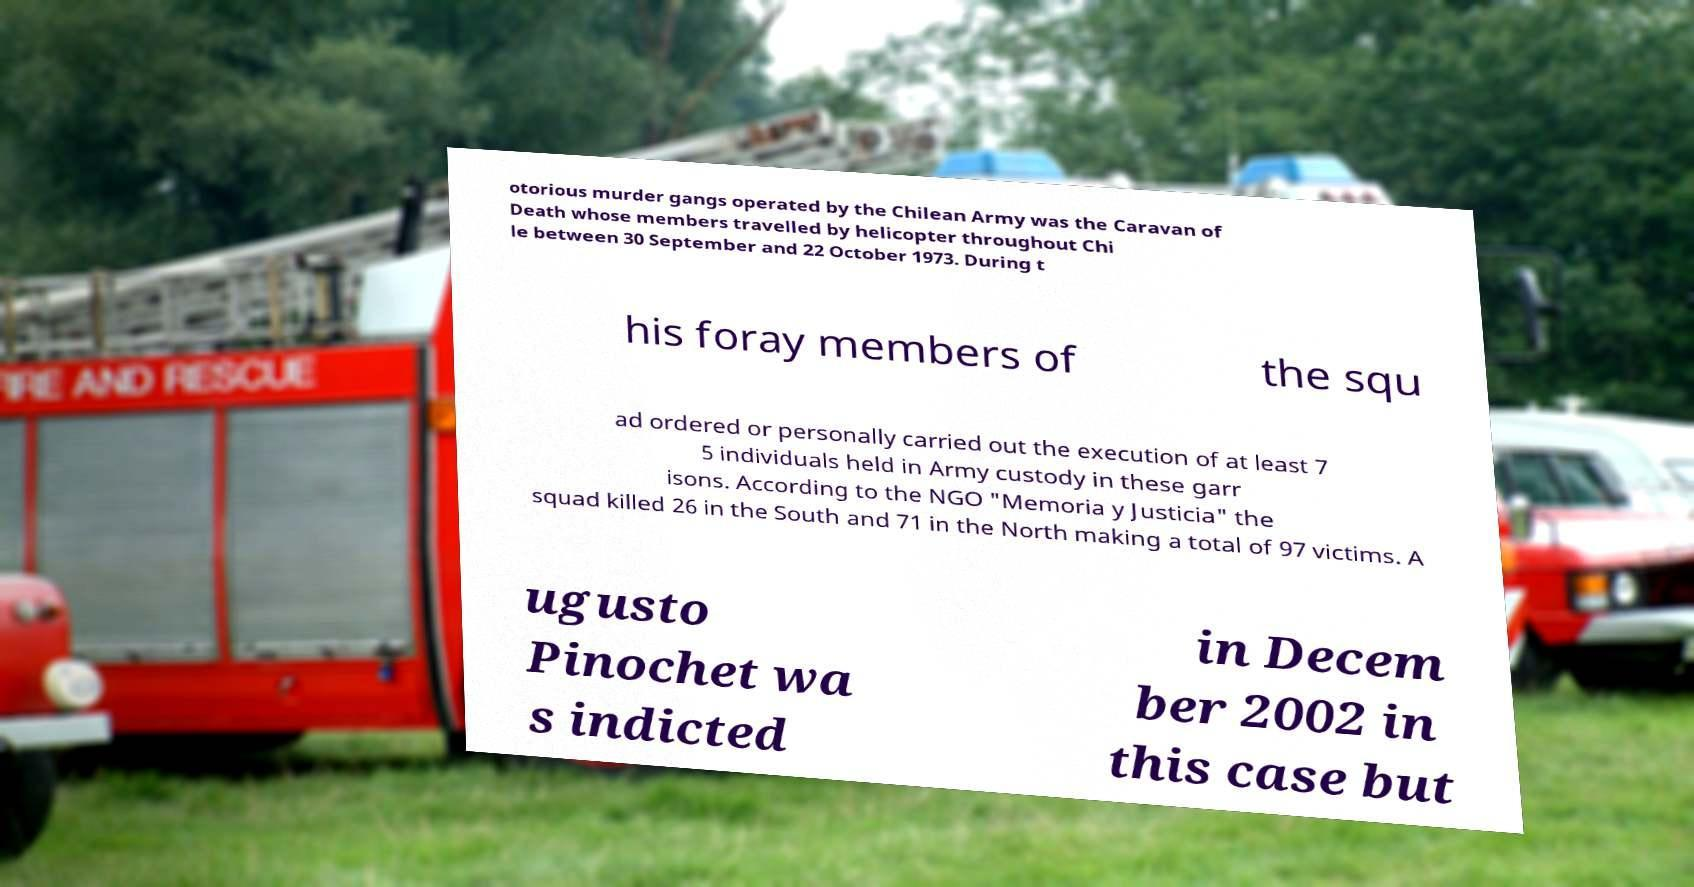Could you assist in decoding the text presented in this image and type it out clearly? otorious murder gangs operated by the Chilean Army was the Caravan of Death whose members travelled by helicopter throughout Chi le between 30 September and 22 October 1973. During t his foray members of the squ ad ordered or personally carried out the execution of at least 7 5 individuals held in Army custody in these garr isons. According to the NGO "Memoria y Justicia" the squad killed 26 in the South and 71 in the North making a total of 97 victims. A ugusto Pinochet wa s indicted in Decem ber 2002 in this case but 